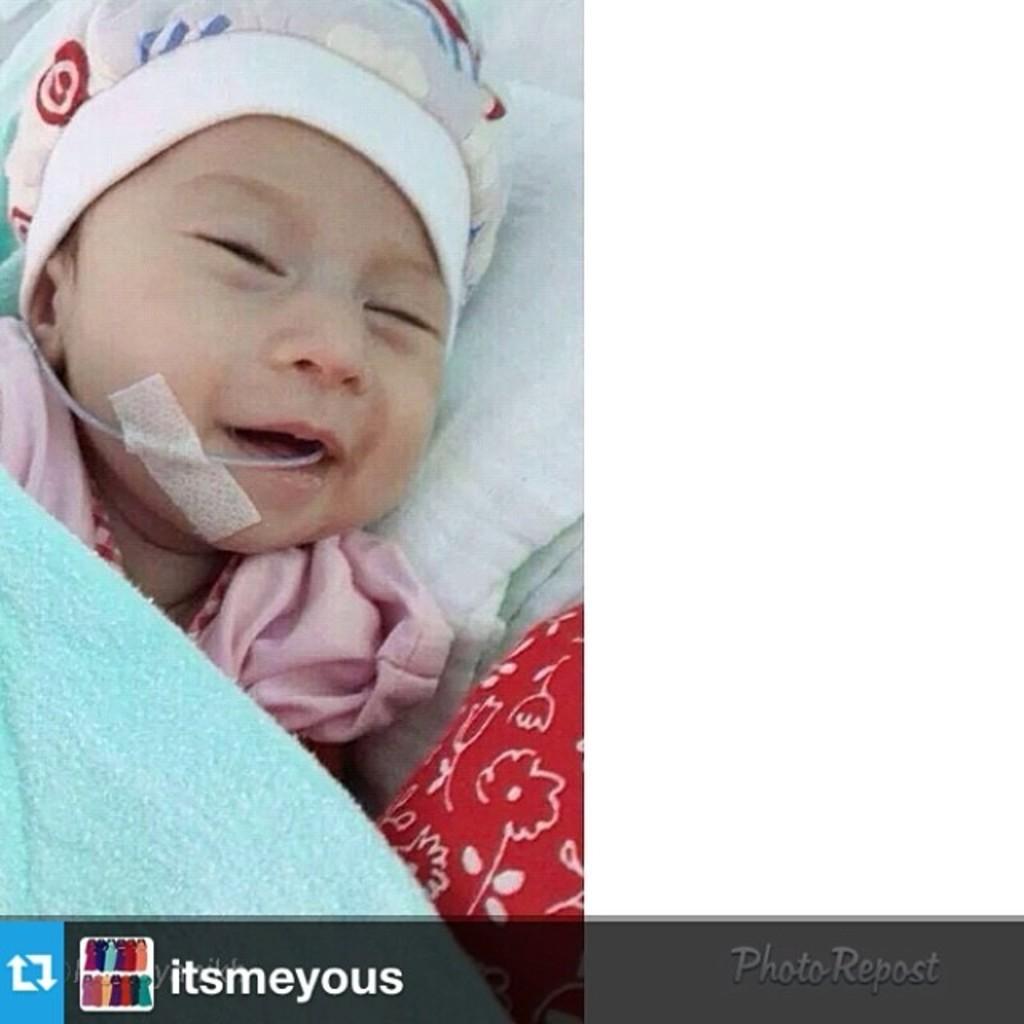Can you describe this image briefly? This image consists of a kid sleeping. In the front, we can see a towel in blue color. At the bottom, there is a white cloth. 